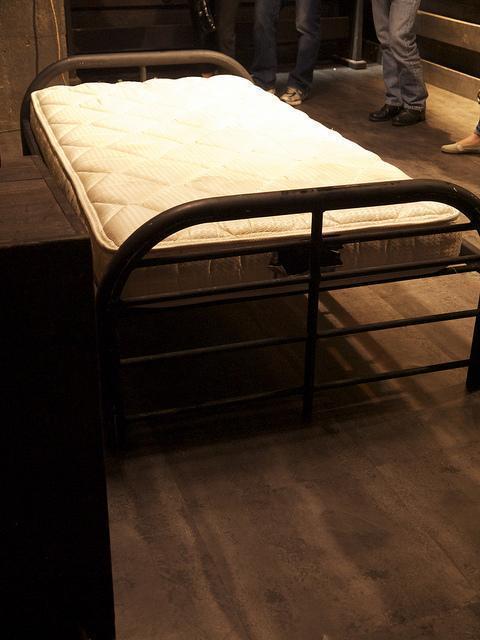What usually happens on the item in the middle of the room?
From the following set of four choices, select the accurate answer to respond to the question.
Options: Cooking, hitting homeruns, shooting hoops, sleeping. Sleeping. 